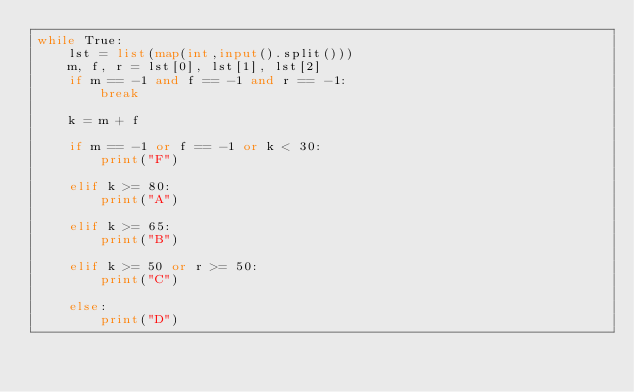<code> <loc_0><loc_0><loc_500><loc_500><_Python_>while True:
    lst = list(map(int,input().split()))
    m, f, r = lst[0], lst[1], lst[2]
    if m == -1 and f == -1 and r == -1:
        break

    k = m + f

    if m == -1 or f == -1 or k < 30:
        print("F") 

    elif k >= 80:
        print("A")

    elif k >= 65:
        print("B")
    
    elif k >= 50 or r >= 50:
        print("C")
    
    else:
        print("D")

</code> 